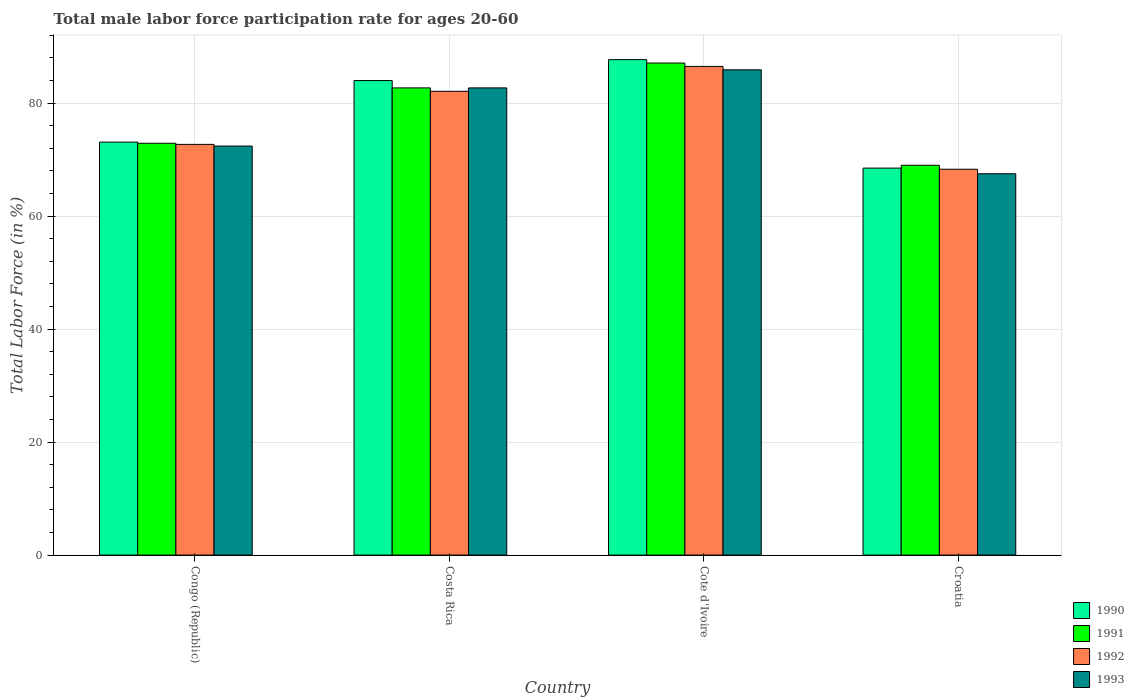How many different coloured bars are there?
Your answer should be very brief. 4. How many groups of bars are there?
Offer a very short reply. 4. Are the number of bars on each tick of the X-axis equal?
Your answer should be very brief. Yes. What is the label of the 4th group of bars from the left?
Provide a succinct answer. Croatia. In how many cases, is the number of bars for a given country not equal to the number of legend labels?
Your response must be concise. 0. What is the male labor force participation rate in 1991 in Cote d'Ivoire?
Keep it short and to the point. 87.1. Across all countries, what is the maximum male labor force participation rate in 1992?
Give a very brief answer. 86.5. Across all countries, what is the minimum male labor force participation rate in 1990?
Offer a terse response. 68.5. In which country was the male labor force participation rate in 1991 maximum?
Your response must be concise. Cote d'Ivoire. In which country was the male labor force participation rate in 1990 minimum?
Offer a very short reply. Croatia. What is the total male labor force participation rate in 1992 in the graph?
Your response must be concise. 309.6. What is the difference between the male labor force participation rate in 1990 in Congo (Republic) and that in Costa Rica?
Provide a short and direct response. -10.9. What is the difference between the male labor force participation rate in 1990 in Croatia and the male labor force participation rate in 1991 in Cote d'Ivoire?
Give a very brief answer. -18.6. What is the average male labor force participation rate in 1990 per country?
Your answer should be compact. 78.32. What is the difference between the male labor force participation rate of/in 1991 and male labor force participation rate of/in 1990 in Costa Rica?
Offer a very short reply. -1.3. In how many countries, is the male labor force participation rate in 1992 greater than 8 %?
Provide a short and direct response. 4. What is the ratio of the male labor force participation rate in 1991 in Costa Rica to that in Croatia?
Provide a succinct answer. 1.2. Is the male labor force participation rate in 1992 in Costa Rica less than that in Cote d'Ivoire?
Your answer should be very brief. Yes. Is the difference between the male labor force participation rate in 1991 in Costa Rica and Croatia greater than the difference between the male labor force participation rate in 1990 in Costa Rica and Croatia?
Give a very brief answer. No. What is the difference between the highest and the second highest male labor force participation rate in 1991?
Offer a terse response. -9.8. What is the difference between the highest and the lowest male labor force participation rate in 1992?
Provide a short and direct response. 18.2. In how many countries, is the male labor force participation rate in 1991 greater than the average male labor force participation rate in 1991 taken over all countries?
Your answer should be very brief. 2. Is it the case that in every country, the sum of the male labor force participation rate in 1991 and male labor force participation rate in 1993 is greater than the sum of male labor force participation rate in 1990 and male labor force participation rate in 1992?
Make the answer very short. No. What does the 1st bar from the left in Congo (Republic) represents?
Give a very brief answer. 1990. What does the 1st bar from the right in Congo (Republic) represents?
Offer a very short reply. 1993. How many bars are there?
Provide a short and direct response. 16. Are all the bars in the graph horizontal?
Your answer should be very brief. No. How many countries are there in the graph?
Provide a succinct answer. 4. What is the difference between two consecutive major ticks on the Y-axis?
Make the answer very short. 20. Does the graph contain any zero values?
Give a very brief answer. No. Does the graph contain grids?
Your answer should be very brief. Yes. How are the legend labels stacked?
Your response must be concise. Vertical. What is the title of the graph?
Provide a succinct answer. Total male labor force participation rate for ages 20-60. What is the label or title of the X-axis?
Provide a succinct answer. Country. What is the Total Labor Force (in %) in 1990 in Congo (Republic)?
Provide a short and direct response. 73.1. What is the Total Labor Force (in %) in 1991 in Congo (Republic)?
Ensure brevity in your answer.  72.9. What is the Total Labor Force (in %) in 1992 in Congo (Republic)?
Provide a short and direct response. 72.7. What is the Total Labor Force (in %) in 1993 in Congo (Republic)?
Your answer should be very brief. 72.4. What is the Total Labor Force (in %) in 1991 in Costa Rica?
Offer a terse response. 82.7. What is the Total Labor Force (in %) in 1992 in Costa Rica?
Offer a very short reply. 82.1. What is the Total Labor Force (in %) in 1993 in Costa Rica?
Your response must be concise. 82.7. What is the Total Labor Force (in %) of 1990 in Cote d'Ivoire?
Your answer should be very brief. 87.7. What is the Total Labor Force (in %) in 1991 in Cote d'Ivoire?
Your answer should be compact. 87.1. What is the Total Labor Force (in %) in 1992 in Cote d'Ivoire?
Provide a succinct answer. 86.5. What is the Total Labor Force (in %) in 1993 in Cote d'Ivoire?
Ensure brevity in your answer.  85.9. What is the Total Labor Force (in %) of 1990 in Croatia?
Ensure brevity in your answer.  68.5. What is the Total Labor Force (in %) in 1991 in Croatia?
Offer a very short reply. 69. What is the Total Labor Force (in %) in 1992 in Croatia?
Offer a very short reply. 68.3. What is the Total Labor Force (in %) of 1993 in Croatia?
Your answer should be very brief. 67.5. Across all countries, what is the maximum Total Labor Force (in %) of 1990?
Your answer should be compact. 87.7. Across all countries, what is the maximum Total Labor Force (in %) in 1991?
Make the answer very short. 87.1. Across all countries, what is the maximum Total Labor Force (in %) of 1992?
Make the answer very short. 86.5. Across all countries, what is the maximum Total Labor Force (in %) of 1993?
Offer a very short reply. 85.9. Across all countries, what is the minimum Total Labor Force (in %) in 1990?
Offer a terse response. 68.5. Across all countries, what is the minimum Total Labor Force (in %) in 1991?
Provide a succinct answer. 69. Across all countries, what is the minimum Total Labor Force (in %) in 1992?
Ensure brevity in your answer.  68.3. Across all countries, what is the minimum Total Labor Force (in %) of 1993?
Give a very brief answer. 67.5. What is the total Total Labor Force (in %) of 1990 in the graph?
Your answer should be very brief. 313.3. What is the total Total Labor Force (in %) in 1991 in the graph?
Offer a terse response. 311.7. What is the total Total Labor Force (in %) in 1992 in the graph?
Ensure brevity in your answer.  309.6. What is the total Total Labor Force (in %) in 1993 in the graph?
Your response must be concise. 308.5. What is the difference between the Total Labor Force (in %) in 1991 in Congo (Republic) and that in Costa Rica?
Your answer should be very brief. -9.8. What is the difference between the Total Labor Force (in %) in 1992 in Congo (Republic) and that in Costa Rica?
Offer a very short reply. -9.4. What is the difference between the Total Labor Force (in %) in 1993 in Congo (Republic) and that in Costa Rica?
Provide a succinct answer. -10.3. What is the difference between the Total Labor Force (in %) of 1990 in Congo (Republic) and that in Cote d'Ivoire?
Your response must be concise. -14.6. What is the difference between the Total Labor Force (in %) in 1991 in Congo (Republic) and that in Cote d'Ivoire?
Make the answer very short. -14.2. What is the difference between the Total Labor Force (in %) in 1993 in Congo (Republic) and that in Cote d'Ivoire?
Your response must be concise. -13.5. What is the difference between the Total Labor Force (in %) of 1992 in Congo (Republic) and that in Croatia?
Offer a very short reply. 4.4. What is the difference between the Total Labor Force (in %) in 1990 in Costa Rica and that in Cote d'Ivoire?
Provide a short and direct response. -3.7. What is the difference between the Total Labor Force (in %) in 1991 in Costa Rica and that in Croatia?
Provide a succinct answer. 13.7. What is the difference between the Total Labor Force (in %) in 1992 in Cote d'Ivoire and that in Croatia?
Your response must be concise. 18.2. What is the difference between the Total Labor Force (in %) of 1990 in Congo (Republic) and the Total Labor Force (in %) of 1993 in Costa Rica?
Your answer should be compact. -9.6. What is the difference between the Total Labor Force (in %) in 1991 in Congo (Republic) and the Total Labor Force (in %) in 1992 in Costa Rica?
Make the answer very short. -9.2. What is the difference between the Total Labor Force (in %) in 1992 in Congo (Republic) and the Total Labor Force (in %) in 1993 in Costa Rica?
Provide a succinct answer. -10. What is the difference between the Total Labor Force (in %) in 1990 in Congo (Republic) and the Total Labor Force (in %) in 1992 in Cote d'Ivoire?
Provide a short and direct response. -13.4. What is the difference between the Total Labor Force (in %) of 1991 in Congo (Republic) and the Total Labor Force (in %) of 1992 in Cote d'Ivoire?
Offer a very short reply. -13.6. What is the difference between the Total Labor Force (in %) of 1990 in Congo (Republic) and the Total Labor Force (in %) of 1993 in Croatia?
Provide a succinct answer. 5.6. What is the difference between the Total Labor Force (in %) in 1991 in Congo (Republic) and the Total Labor Force (in %) in 1992 in Croatia?
Make the answer very short. 4.6. What is the difference between the Total Labor Force (in %) in 1992 in Congo (Republic) and the Total Labor Force (in %) in 1993 in Croatia?
Your answer should be compact. 5.2. What is the difference between the Total Labor Force (in %) of 1990 in Costa Rica and the Total Labor Force (in %) of 1991 in Cote d'Ivoire?
Provide a succinct answer. -3.1. What is the difference between the Total Labor Force (in %) in 1991 in Costa Rica and the Total Labor Force (in %) in 1993 in Cote d'Ivoire?
Ensure brevity in your answer.  -3.2. What is the difference between the Total Labor Force (in %) of 1990 in Costa Rica and the Total Labor Force (in %) of 1991 in Croatia?
Offer a terse response. 15. What is the difference between the Total Labor Force (in %) in 1990 in Costa Rica and the Total Labor Force (in %) in 1993 in Croatia?
Your answer should be compact. 16.5. What is the difference between the Total Labor Force (in %) in 1991 in Costa Rica and the Total Labor Force (in %) in 1992 in Croatia?
Your response must be concise. 14.4. What is the difference between the Total Labor Force (in %) of 1991 in Costa Rica and the Total Labor Force (in %) of 1993 in Croatia?
Provide a short and direct response. 15.2. What is the difference between the Total Labor Force (in %) in 1992 in Costa Rica and the Total Labor Force (in %) in 1993 in Croatia?
Your answer should be compact. 14.6. What is the difference between the Total Labor Force (in %) in 1990 in Cote d'Ivoire and the Total Labor Force (in %) in 1992 in Croatia?
Offer a very short reply. 19.4. What is the difference between the Total Labor Force (in %) of 1990 in Cote d'Ivoire and the Total Labor Force (in %) of 1993 in Croatia?
Offer a very short reply. 20.2. What is the difference between the Total Labor Force (in %) of 1991 in Cote d'Ivoire and the Total Labor Force (in %) of 1993 in Croatia?
Keep it short and to the point. 19.6. What is the difference between the Total Labor Force (in %) in 1992 in Cote d'Ivoire and the Total Labor Force (in %) in 1993 in Croatia?
Make the answer very short. 19. What is the average Total Labor Force (in %) in 1990 per country?
Keep it short and to the point. 78.33. What is the average Total Labor Force (in %) of 1991 per country?
Give a very brief answer. 77.92. What is the average Total Labor Force (in %) of 1992 per country?
Give a very brief answer. 77.4. What is the average Total Labor Force (in %) in 1993 per country?
Make the answer very short. 77.12. What is the difference between the Total Labor Force (in %) in 1990 and Total Labor Force (in %) in 1993 in Congo (Republic)?
Offer a very short reply. 0.7. What is the difference between the Total Labor Force (in %) of 1991 and Total Labor Force (in %) of 1992 in Congo (Republic)?
Your answer should be very brief. 0.2. What is the difference between the Total Labor Force (in %) of 1992 and Total Labor Force (in %) of 1993 in Congo (Republic)?
Ensure brevity in your answer.  0.3. What is the difference between the Total Labor Force (in %) of 1990 and Total Labor Force (in %) of 1991 in Costa Rica?
Your response must be concise. 1.3. What is the difference between the Total Labor Force (in %) in 1990 and Total Labor Force (in %) in 1992 in Costa Rica?
Make the answer very short. 1.9. What is the difference between the Total Labor Force (in %) of 1990 and Total Labor Force (in %) of 1993 in Costa Rica?
Give a very brief answer. 1.3. What is the difference between the Total Labor Force (in %) of 1991 and Total Labor Force (in %) of 1993 in Cote d'Ivoire?
Provide a short and direct response. 1.2. What is the difference between the Total Labor Force (in %) in 1990 and Total Labor Force (in %) in 1993 in Croatia?
Your answer should be very brief. 1. What is the difference between the Total Labor Force (in %) in 1992 and Total Labor Force (in %) in 1993 in Croatia?
Make the answer very short. 0.8. What is the ratio of the Total Labor Force (in %) in 1990 in Congo (Republic) to that in Costa Rica?
Your response must be concise. 0.87. What is the ratio of the Total Labor Force (in %) of 1991 in Congo (Republic) to that in Costa Rica?
Your response must be concise. 0.88. What is the ratio of the Total Labor Force (in %) in 1992 in Congo (Republic) to that in Costa Rica?
Your answer should be compact. 0.89. What is the ratio of the Total Labor Force (in %) in 1993 in Congo (Republic) to that in Costa Rica?
Offer a terse response. 0.88. What is the ratio of the Total Labor Force (in %) of 1990 in Congo (Republic) to that in Cote d'Ivoire?
Your answer should be very brief. 0.83. What is the ratio of the Total Labor Force (in %) in 1991 in Congo (Republic) to that in Cote d'Ivoire?
Provide a succinct answer. 0.84. What is the ratio of the Total Labor Force (in %) in 1992 in Congo (Republic) to that in Cote d'Ivoire?
Give a very brief answer. 0.84. What is the ratio of the Total Labor Force (in %) in 1993 in Congo (Republic) to that in Cote d'Ivoire?
Provide a short and direct response. 0.84. What is the ratio of the Total Labor Force (in %) of 1990 in Congo (Republic) to that in Croatia?
Provide a short and direct response. 1.07. What is the ratio of the Total Labor Force (in %) of 1991 in Congo (Republic) to that in Croatia?
Offer a very short reply. 1.06. What is the ratio of the Total Labor Force (in %) of 1992 in Congo (Republic) to that in Croatia?
Give a very brief answer. 1.06. What is the ratio of the Total Labor Force (in %) of 1993 in Congo (Republic) to that in Croatia?
Your answer should be compact. 1.07. What is the ratio of the Total Labor Force (in %) of 1990 in Costa Rica to that in Cote d'Ivoire?
Your answer should be very brief. 0.96. What is the ratio of the Total Labor Force (in %) in 1991 in Costa Rica to that in Cote d'Ivoire?
Offer a terse response. 0.95. What is the ratio of the Total Labor Force (in %) in 1992 in Costa Rica to that in Cote d'Ivoire?
Offer a terse response. 0.95. What is the ratio of the Total Labor Force (in %) of 1993 in Costa Rica to that in Cote d'Ivoire?
Provide a succinct answer. 0.96. What is the ratio of the Total Labor Force (in %) of 1990 in Costa Rica to that in Croatia?
Offer a very short reply. 1.23. What is the ratio of the Total Labor Force (in %) in 1991 in Costa Rica to that in Croatia?
Give a very brief answer. 1.2. What is the ratio of the Total Labor Force (in %) of 1992 in Costa Rica to that in Croatia?
Give a very brief answer. 1.2. What is the ratio of the Total Labor Force (in %) in 1993 in Costa Rica to that in Croatia?
Provide a succinct answer. 1.23. What is the ratio of the Total Labor Force (in %) of 1990 in Cote d'Ivoire to that in Croatia?
Provide a short and direct response. 1.28. What is the ratio of the Total Labor Force (in %) in 1991 in Cote d'Ivoire to that in Croatia?
Your answer should be compact. 1.26. What is the ratio of the Total Labor Force (in %) in 1992 in Cote d'Ivoire to that in Croatia?
Make the answer very short. 1.27. What is the ratio of the Total Labor Force (in %) in 1993 in Cote d'Ivoire to that in Croatia?
Offer a terse response. 1.27. What is the difference between the highest and the second highest Total Labor Force (in %) in 1992?
Your answer should be very brief. 4.4. What is the difference between the highest and the second highest Total Labor Force (in %) of 1993?
Your response must be concise. 3.2. What is the difference between the highest and the lowest Total Labor Force (in %) in 1990?
Provide a short and direct response. 19.2. What is the difference between the highest and the lowest Total Labor Force (in %) in 1992?
Provide a short and direct response. 18.2. What is the difference between the highest and the lowest Total Labor Force (in %) in 1993?
Your answer should be very brief. 18.4. 